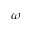<formula> <loc_0><loc_0><loc_500><loc_500>\omega</formula> 